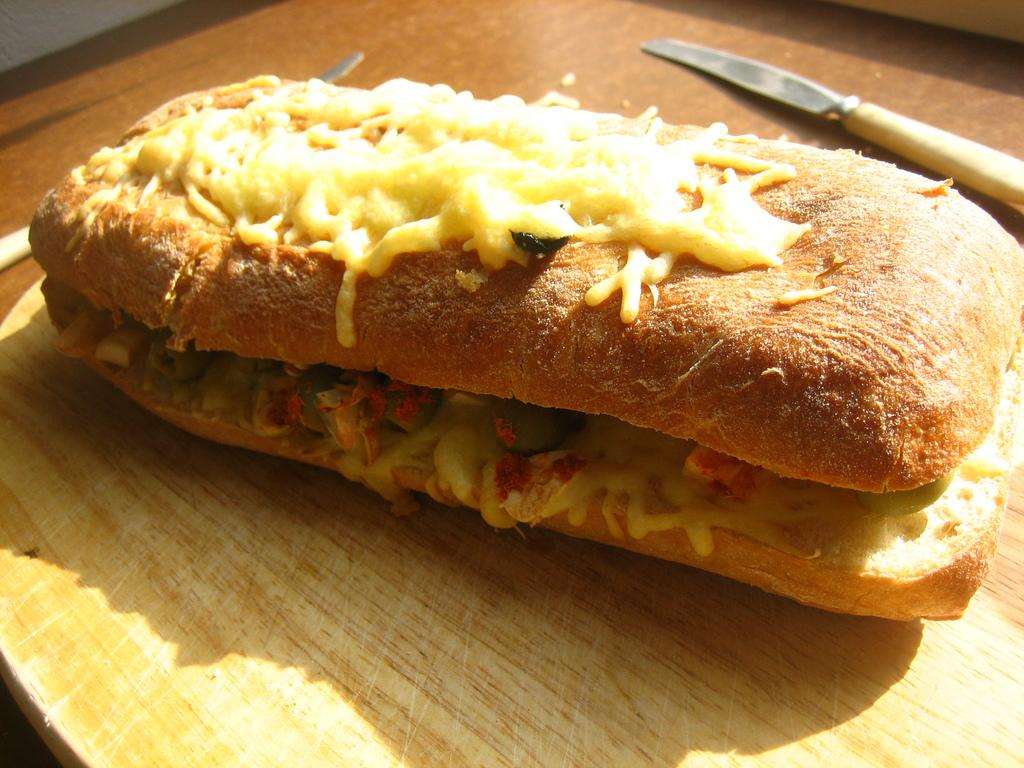What type of food is shown in the image? There is a burger in the image. What utensils are visible in the image? There are two knives in the image. What material is the table made of in the image? The table in the image is made of wood. How many babies are sleeping in the beds in the image? There are no beds or babies present in the image. 